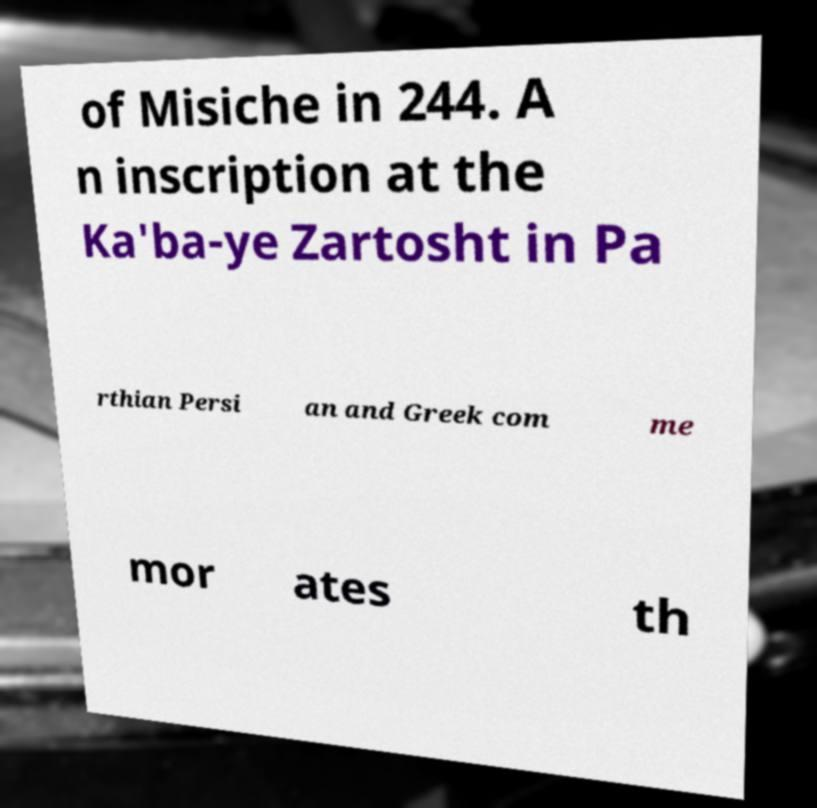Can you read and provide the text displayed in the image?This photo seems to have some interesting text. Can you extract and type it out for me? of Misiche in 244. A n inscription at the Ka'ba-ye Zartosht in Pa rthian Persi an and Greek com me mor ates th 